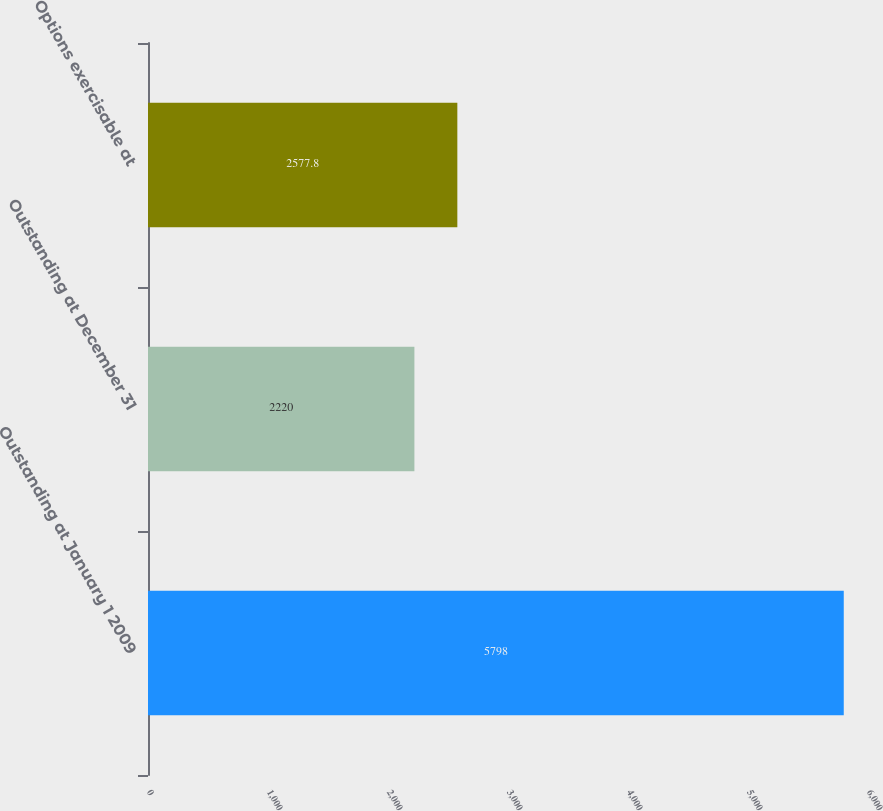Convert chart to OTSL. <chart><loc_0><loc_0><loc_500><loc_500><bar_chart><fcel>Outstanding at January 1 2009<fcel>Outstanding at December 31<fcel>Options exercisable at<nl><fcel>5798<fcel>2220<fcel>2577.8<nl></chart> 